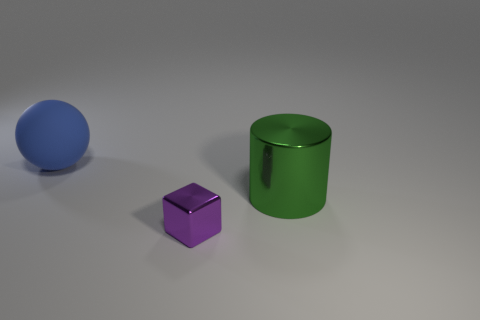Is the shape of the big thing behind the green object the same as  the green shiny object?
Offer a terse response. No. Are there more small blocks behind the block than big blue things?
Give a very brief answer. No. There is a cylinder that is the same size as the rubber ball; what color is it?
Your response must be concise. Green. What number of objects are either large objects that are in front of the ball or tiny purple shiny cubes?
Give a very brief answer. 2. There is a thing to the left of the tiny purple shiny object that is in front of the large green cylinder; what is its material?
Ensure brevity in your answer.  Rubber. Is there a ball that has the same material as the big cylinder?
Make the answer very short. No. Are there any purple metallic things behind the big object right of the big rubber thing?
Your response must be concise. No. There is a blue object that is behind the green cylinder; what material is it?
Provide a short and direct response. Rubber. Is the large blue object the same shape as the green thing?
Keep it short and to the point. No. The large thing to the right of the big object behind the metal object that is behind the tiny block is what color?
Offer a very short reply. Green. 